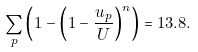<formula> <loc_0><loc_0><loc_500><loc_500>\sum _ { p } \left ( 1 - \left ( 1 - \frac { u _ { p } } { U } \right ) ^ { n } \right ) = 1 3 . 8 .</formula> 